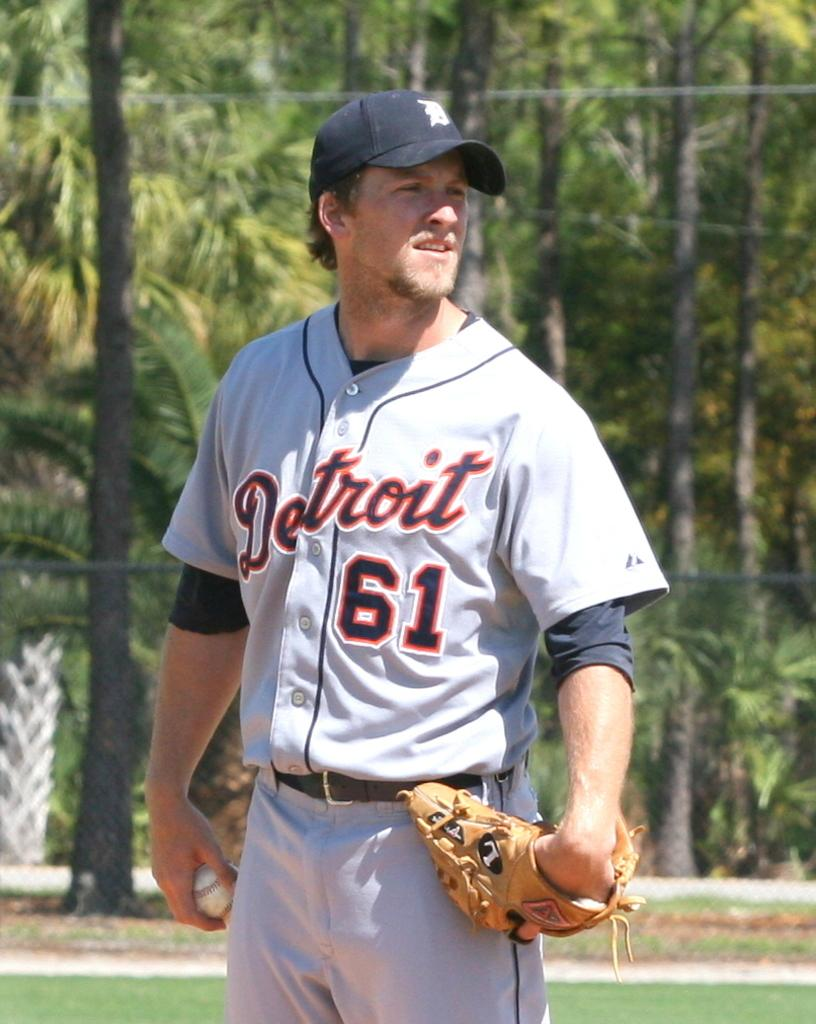<image>
Write a terse but informative summary of the picture. Detriot ballpall player number 61 holding a mitt 